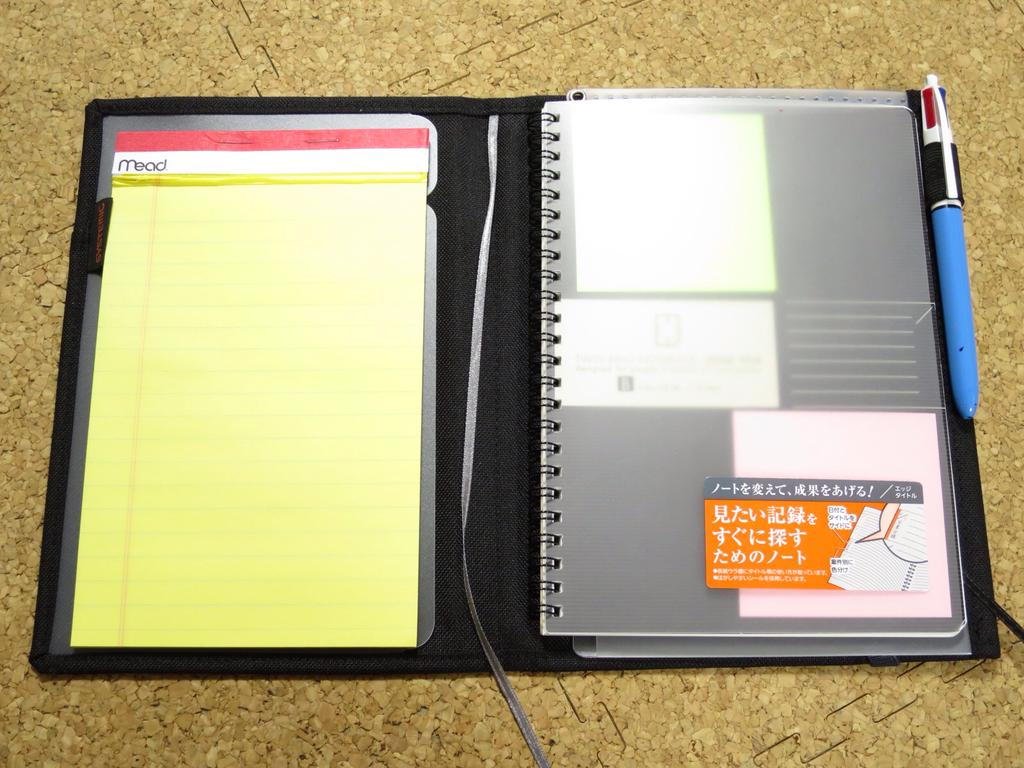What is the main object in the image? There is a diary in the image. What is placed with the diary? There is a pen in the image. Where are the diary and pen located? The diary and pen are on a platform. What type of vegetable is being advised at the event in the image? There is no event, vegetable, or advice present in the image. The image only features a diary and a pen on a platform. 